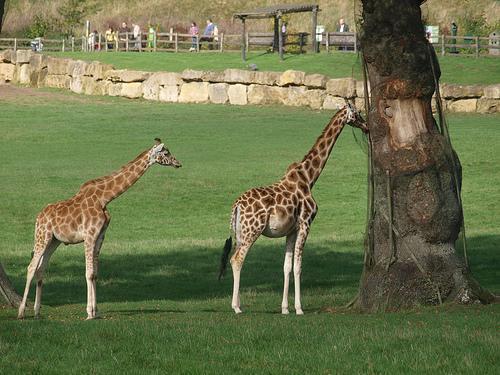How many animals are there?
Give a very brief answer. 2. 